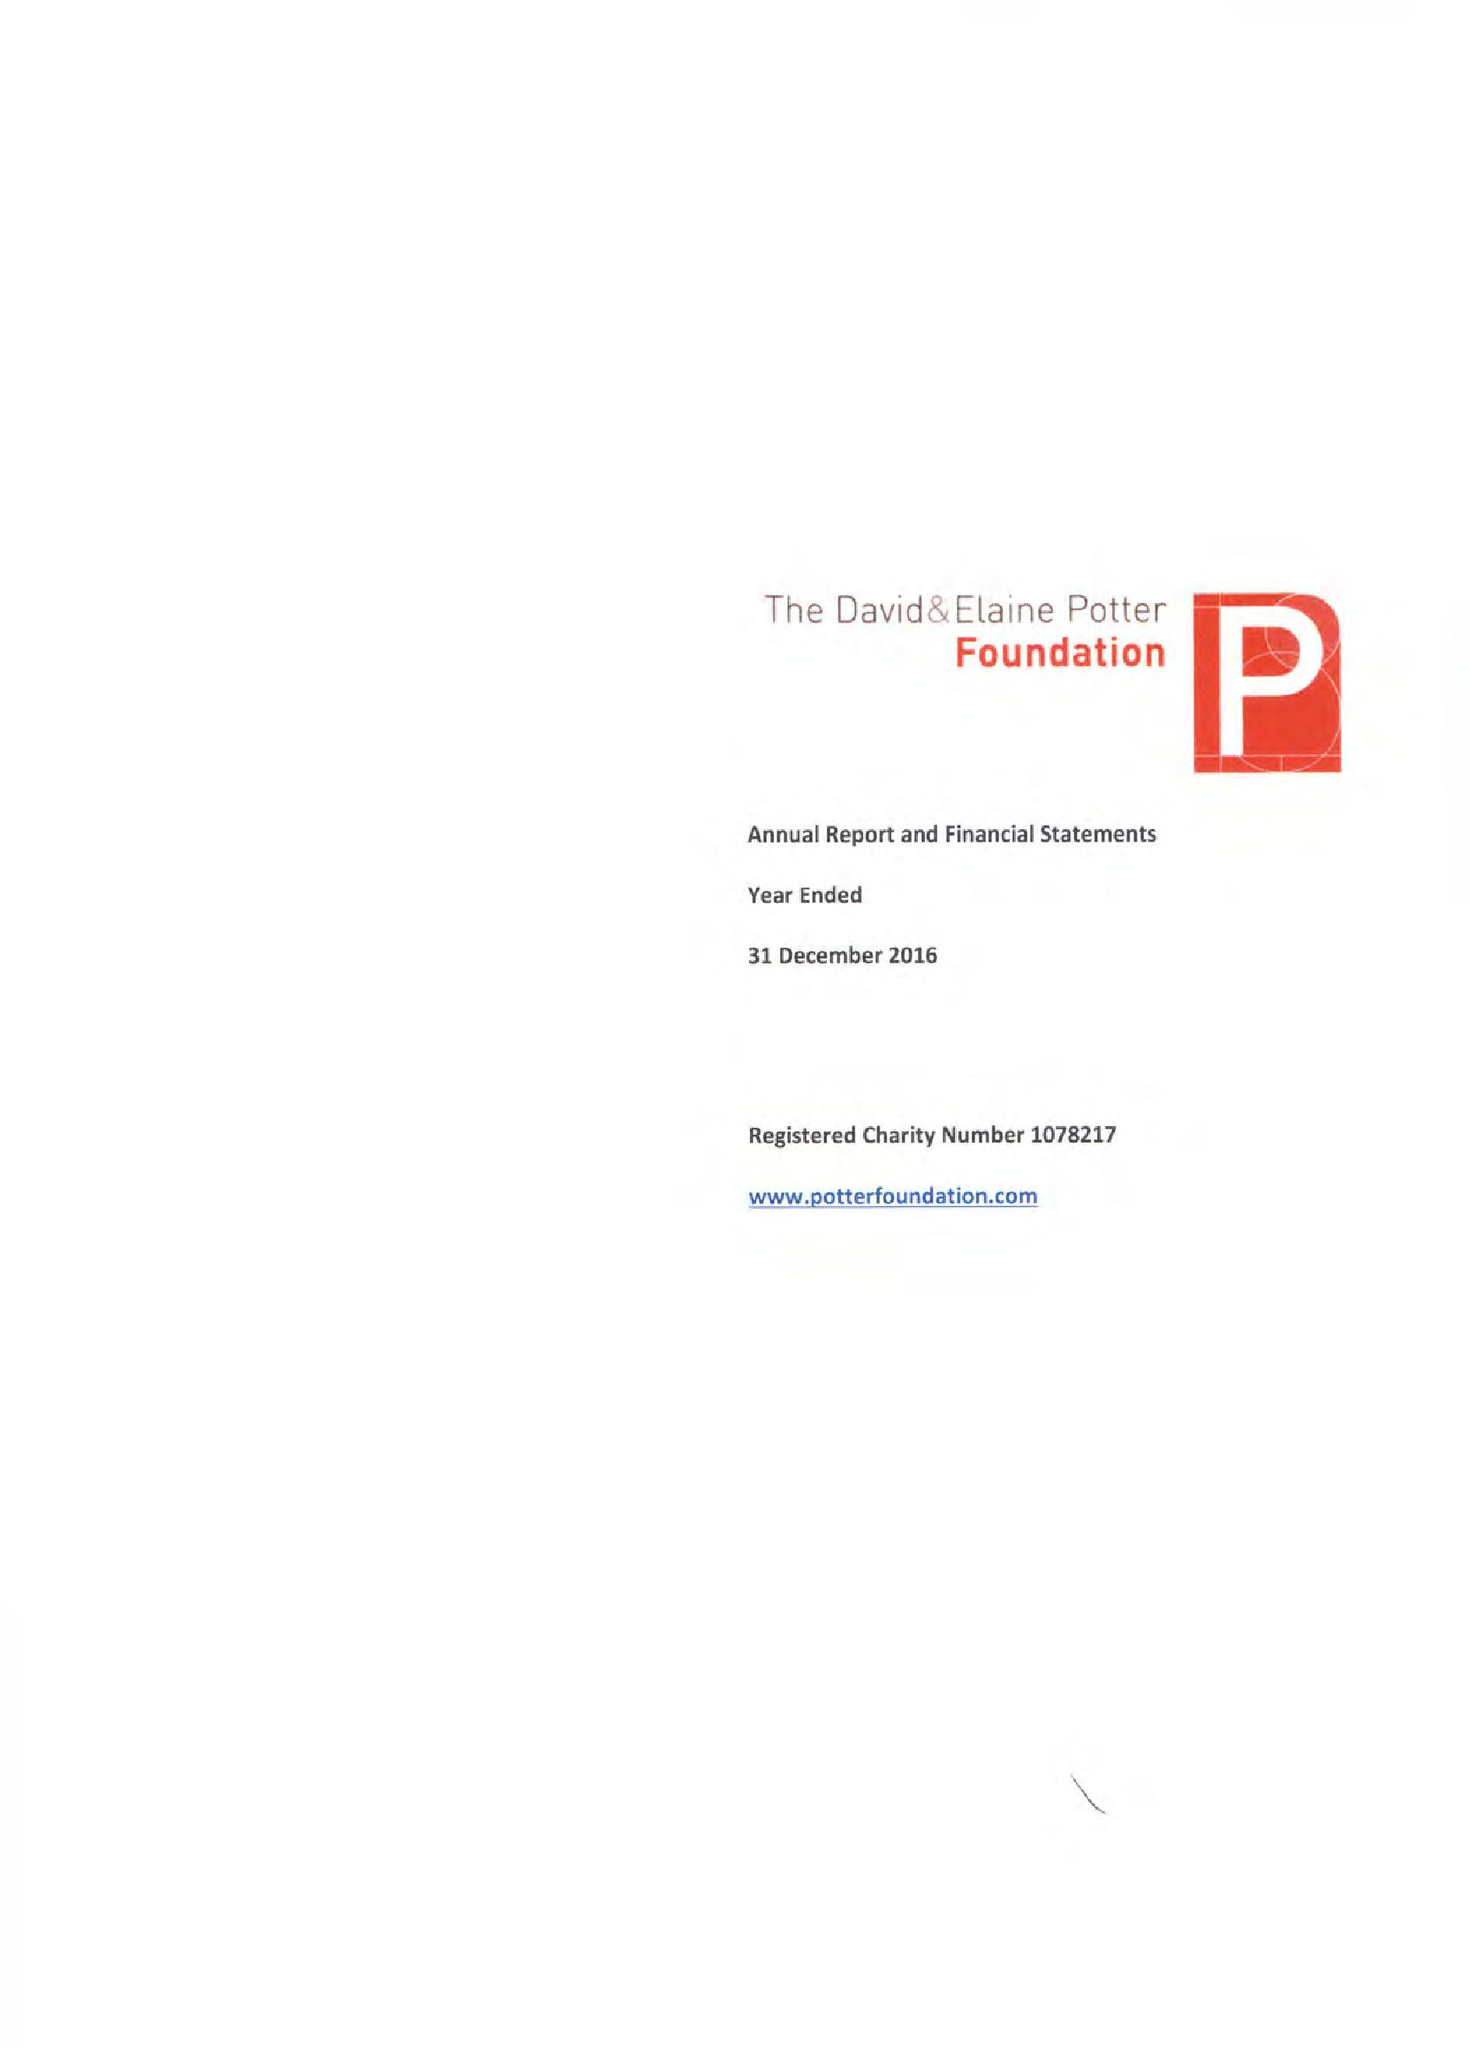What is the value for the charity_number?
Answer the question using a single word or phrase. 1078217 